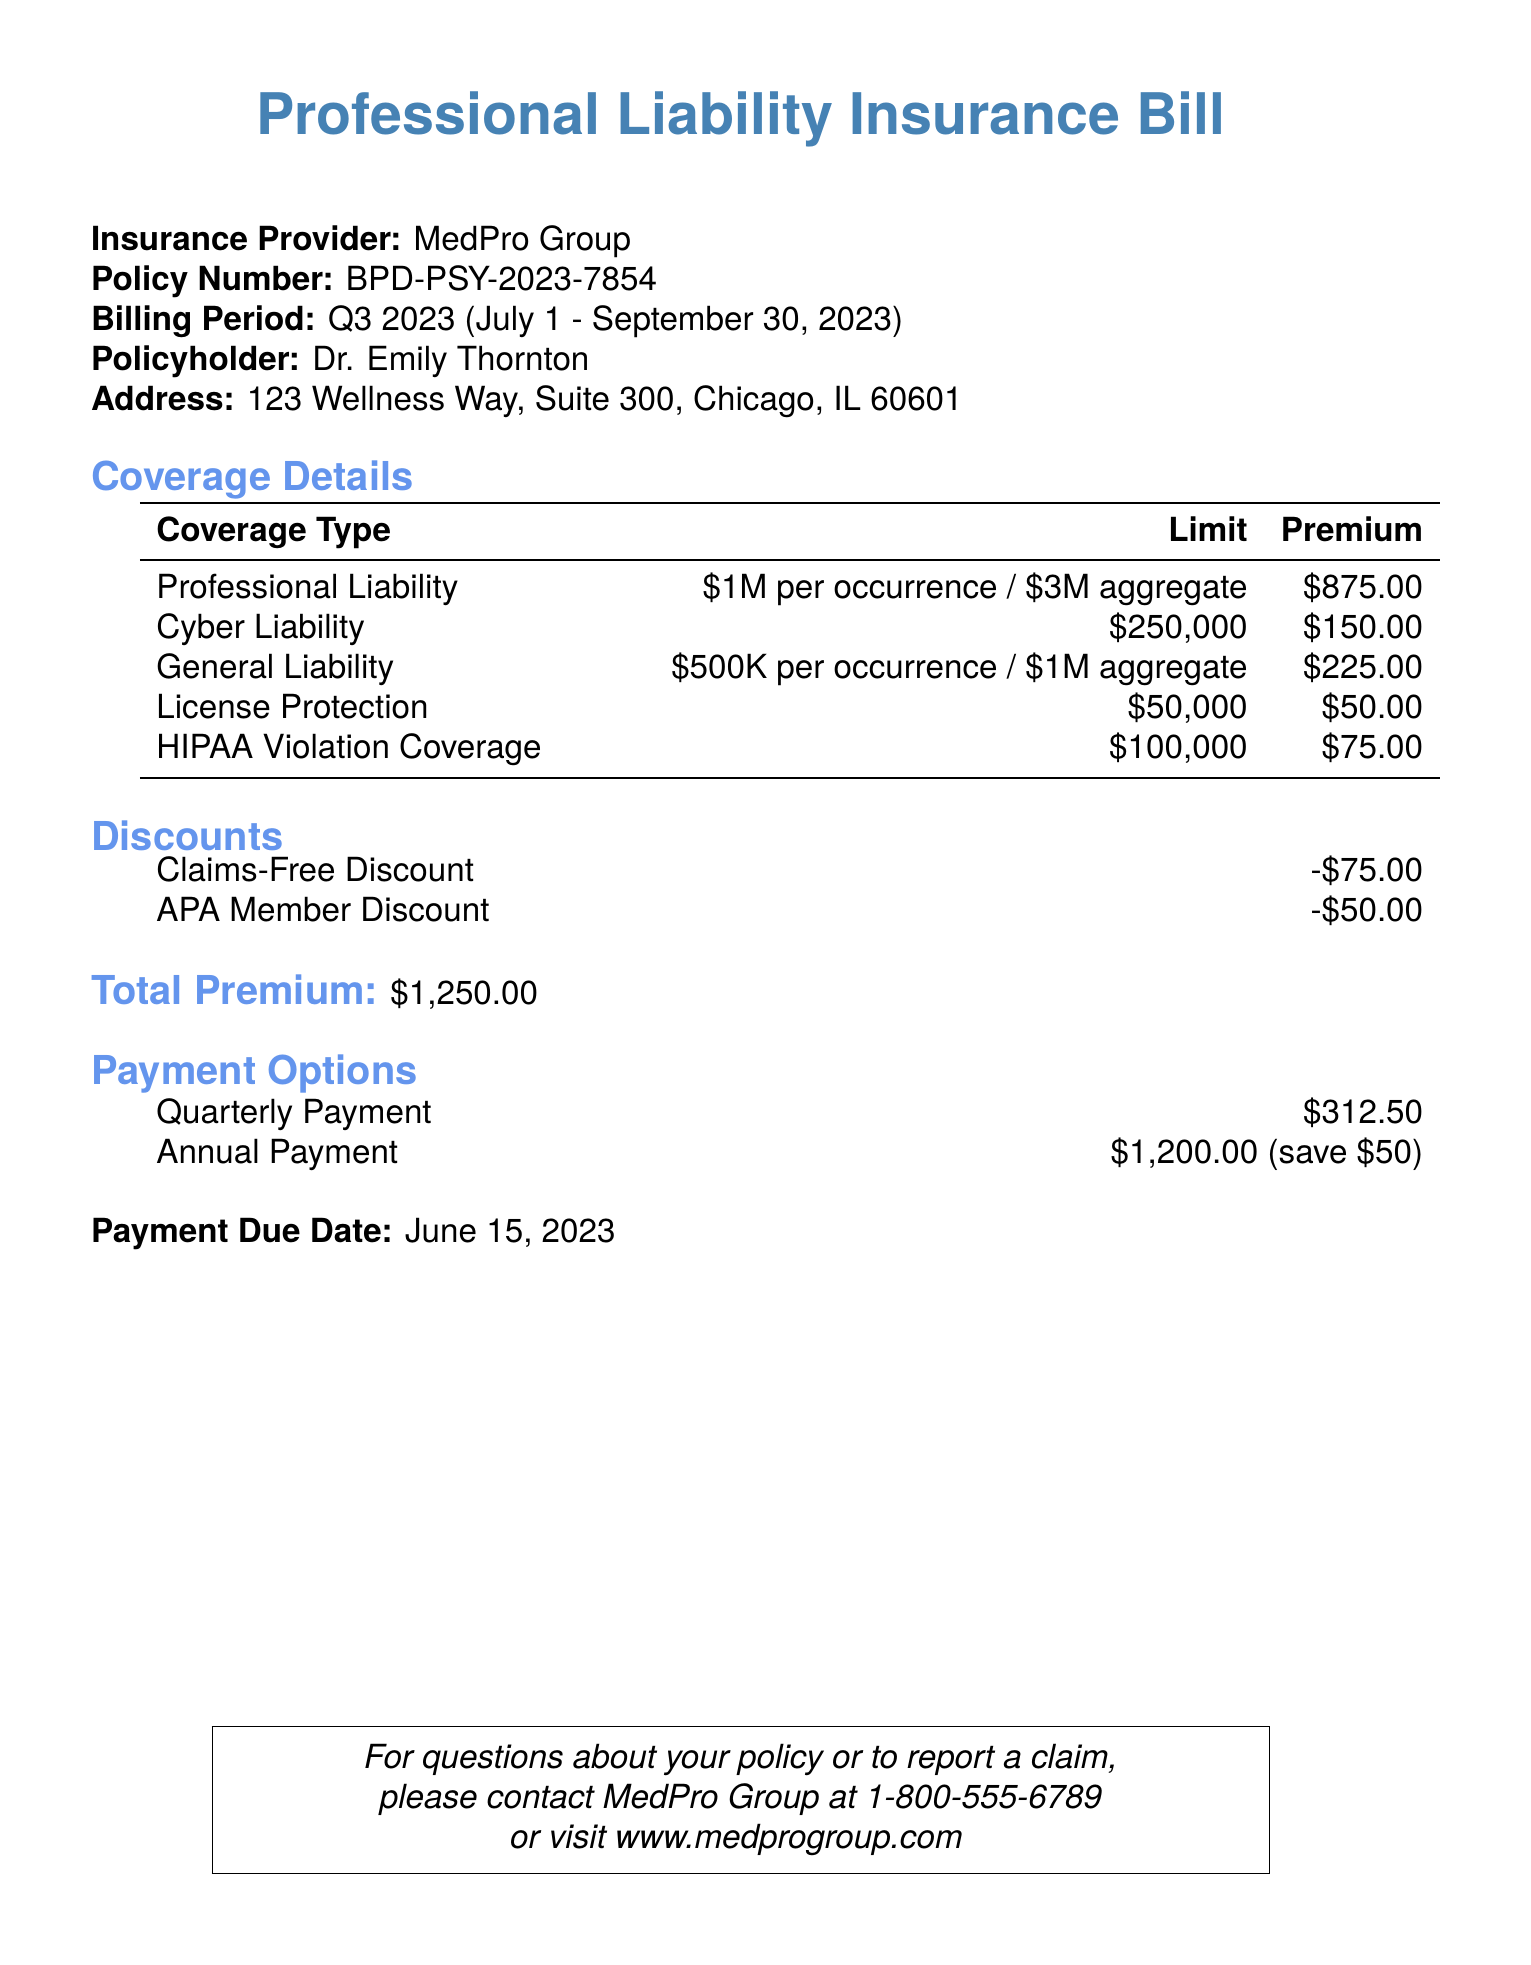What is the insurance provider's name? The document specifies the name of the insurance provider, which is found in the heading section.
Answer: MedPro Group What is the policy number? The policy number is listed in the document under the insurance provider information.
Answer: BPD-PSY-2023-7854 What is the billing period for this insurance? The billing period is clearly stated near the top of the document, indicating the start and end dates.
Answer: Q3 2023 (July 1 - September 30, 2023) What is the total premium before discounts? The total premium is shown clearly at the end of the coverage details section, and is summed up before any discounts are applied.
Answer: $1,250.00 What is the amount of the claims-free discount? The document lists discounts, and the claims-free discount amount is specified there.
Answer: -$75.00 How much is the professional liability coverage limit? The document specifies the coverage limit for professional liability in the coverage details section.
Answer: $1M per occurrence / $3M aggregate What is the premium for cyber liability coverage? The premium for each type of coverage is detailed in the coverage table, including cyber liability.
Answer: $150.00 What are the payment options available? The payment options are listed in a separate section, including details about quarterly and annual payments.
Answer: Quarterly Payment, Annual Payment What is the payment due date? The document mentions the due date for the payment at the end of the billing details.
Answer: June 15, 2023 